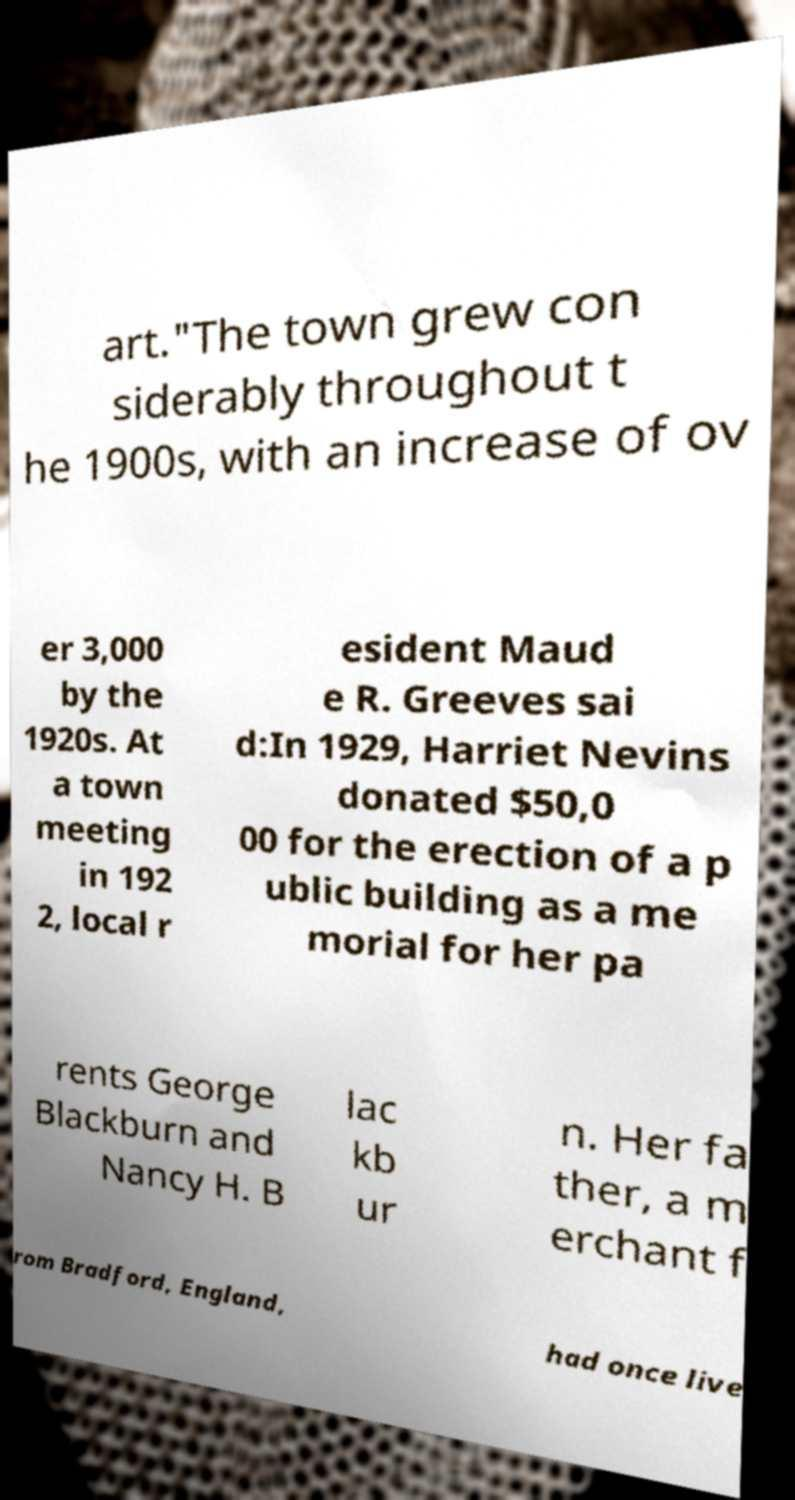Can you accurately transcribe the text from the provided image for me? art."The town grew con siderably throughout t he 1900s, with an increase of ov er 3,000 by the 1920s. At a town meeting in 192 2, local r esident Maud e R. Greeves sai d:In 1929, Harriet Nevins donated $50,0 00 for the erection of a p ublic building as a me morial for her pa rents George Blackburn and Nancy H. B lac kb ur n. Her fa ther, a m erchant f rom Bradford, England, had once live 